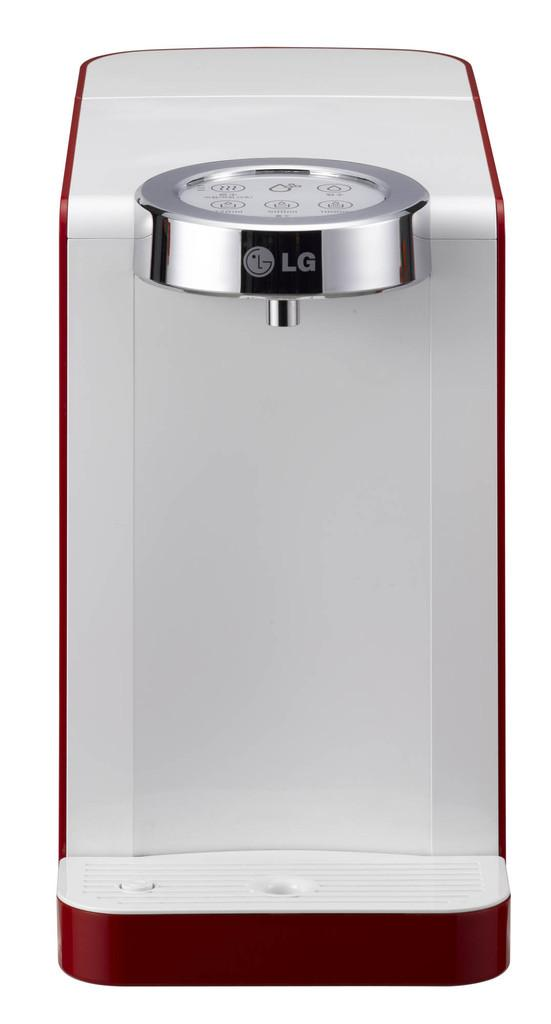<image>
Write a terse but informative summary of the picture. A white LG device with a silver LG ring at the top and a brown base. 